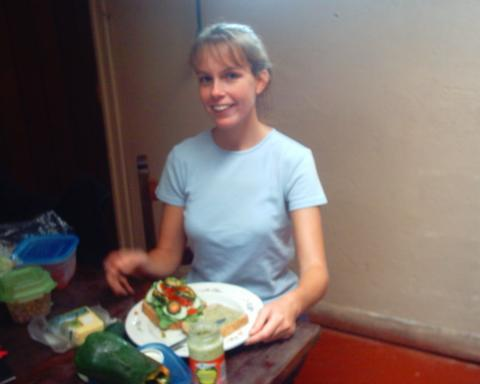What is this woman going to eat? Please explain your reasoning. sandwich. The woman's plate contains two slices of bread, one of which has other foods piled on top of it. 